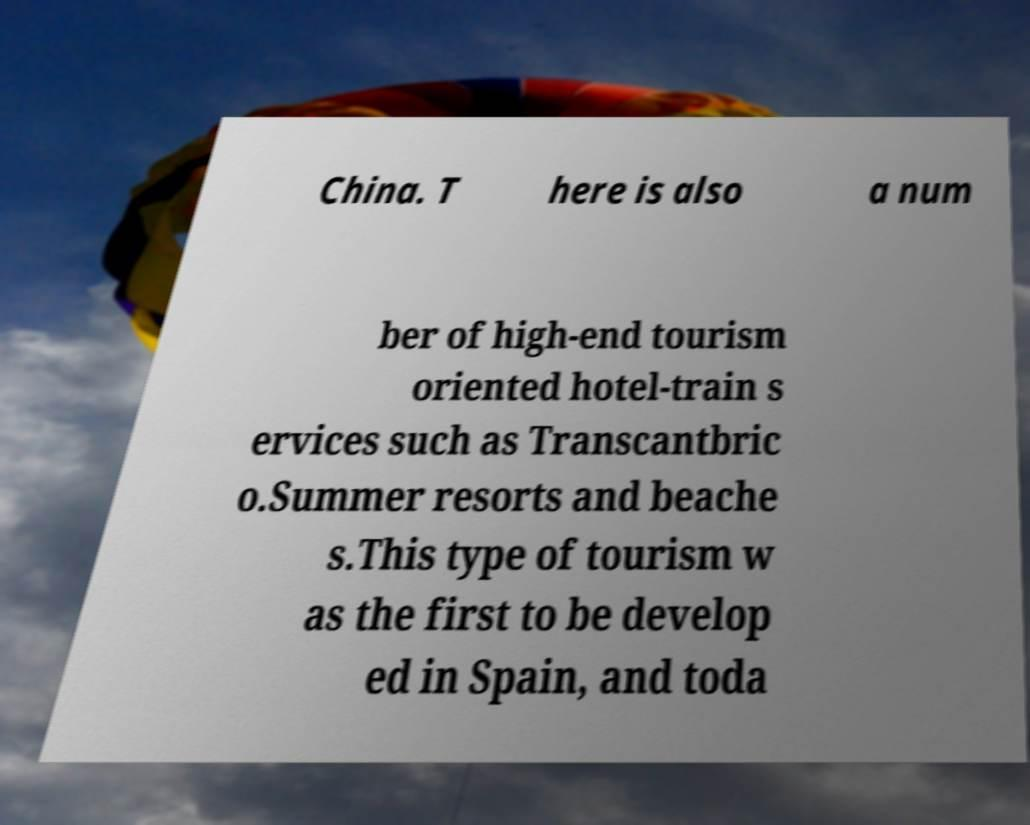For documentation purposes, I need the text within this image transcribed. Could you provide that? China. T here is also a num ber of high-end tourism oriented hotel-train s ervices such as Transcantbric o.Summer resorts and beache s.This type of tourism w as the first to be develop ed in Spain, and toda 